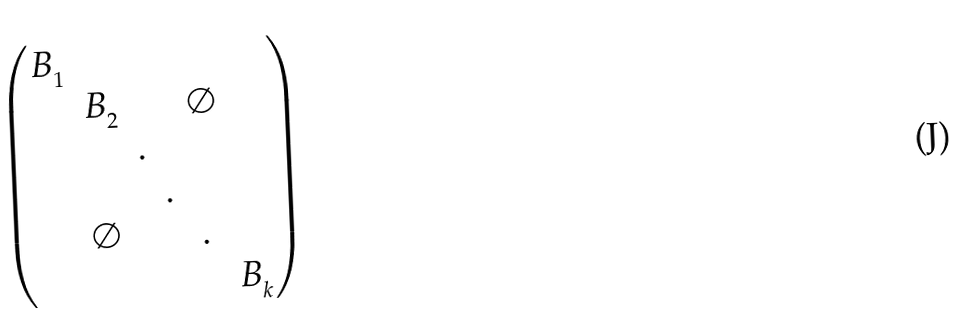Convert formula to latex. <formula><loc_0><loc_0><loc_500><loc_500>\begin{pmatrix} B _ { _ { 1 } } & & & & & \\ & B _ { _ { 2 } } & & & \emptyset & \\ & & . & & & \\ & & & . & & \\ & \emptyset & & & . & \\ & & & & & B _ { _ { k } } \end{pmatrix}</formula> 